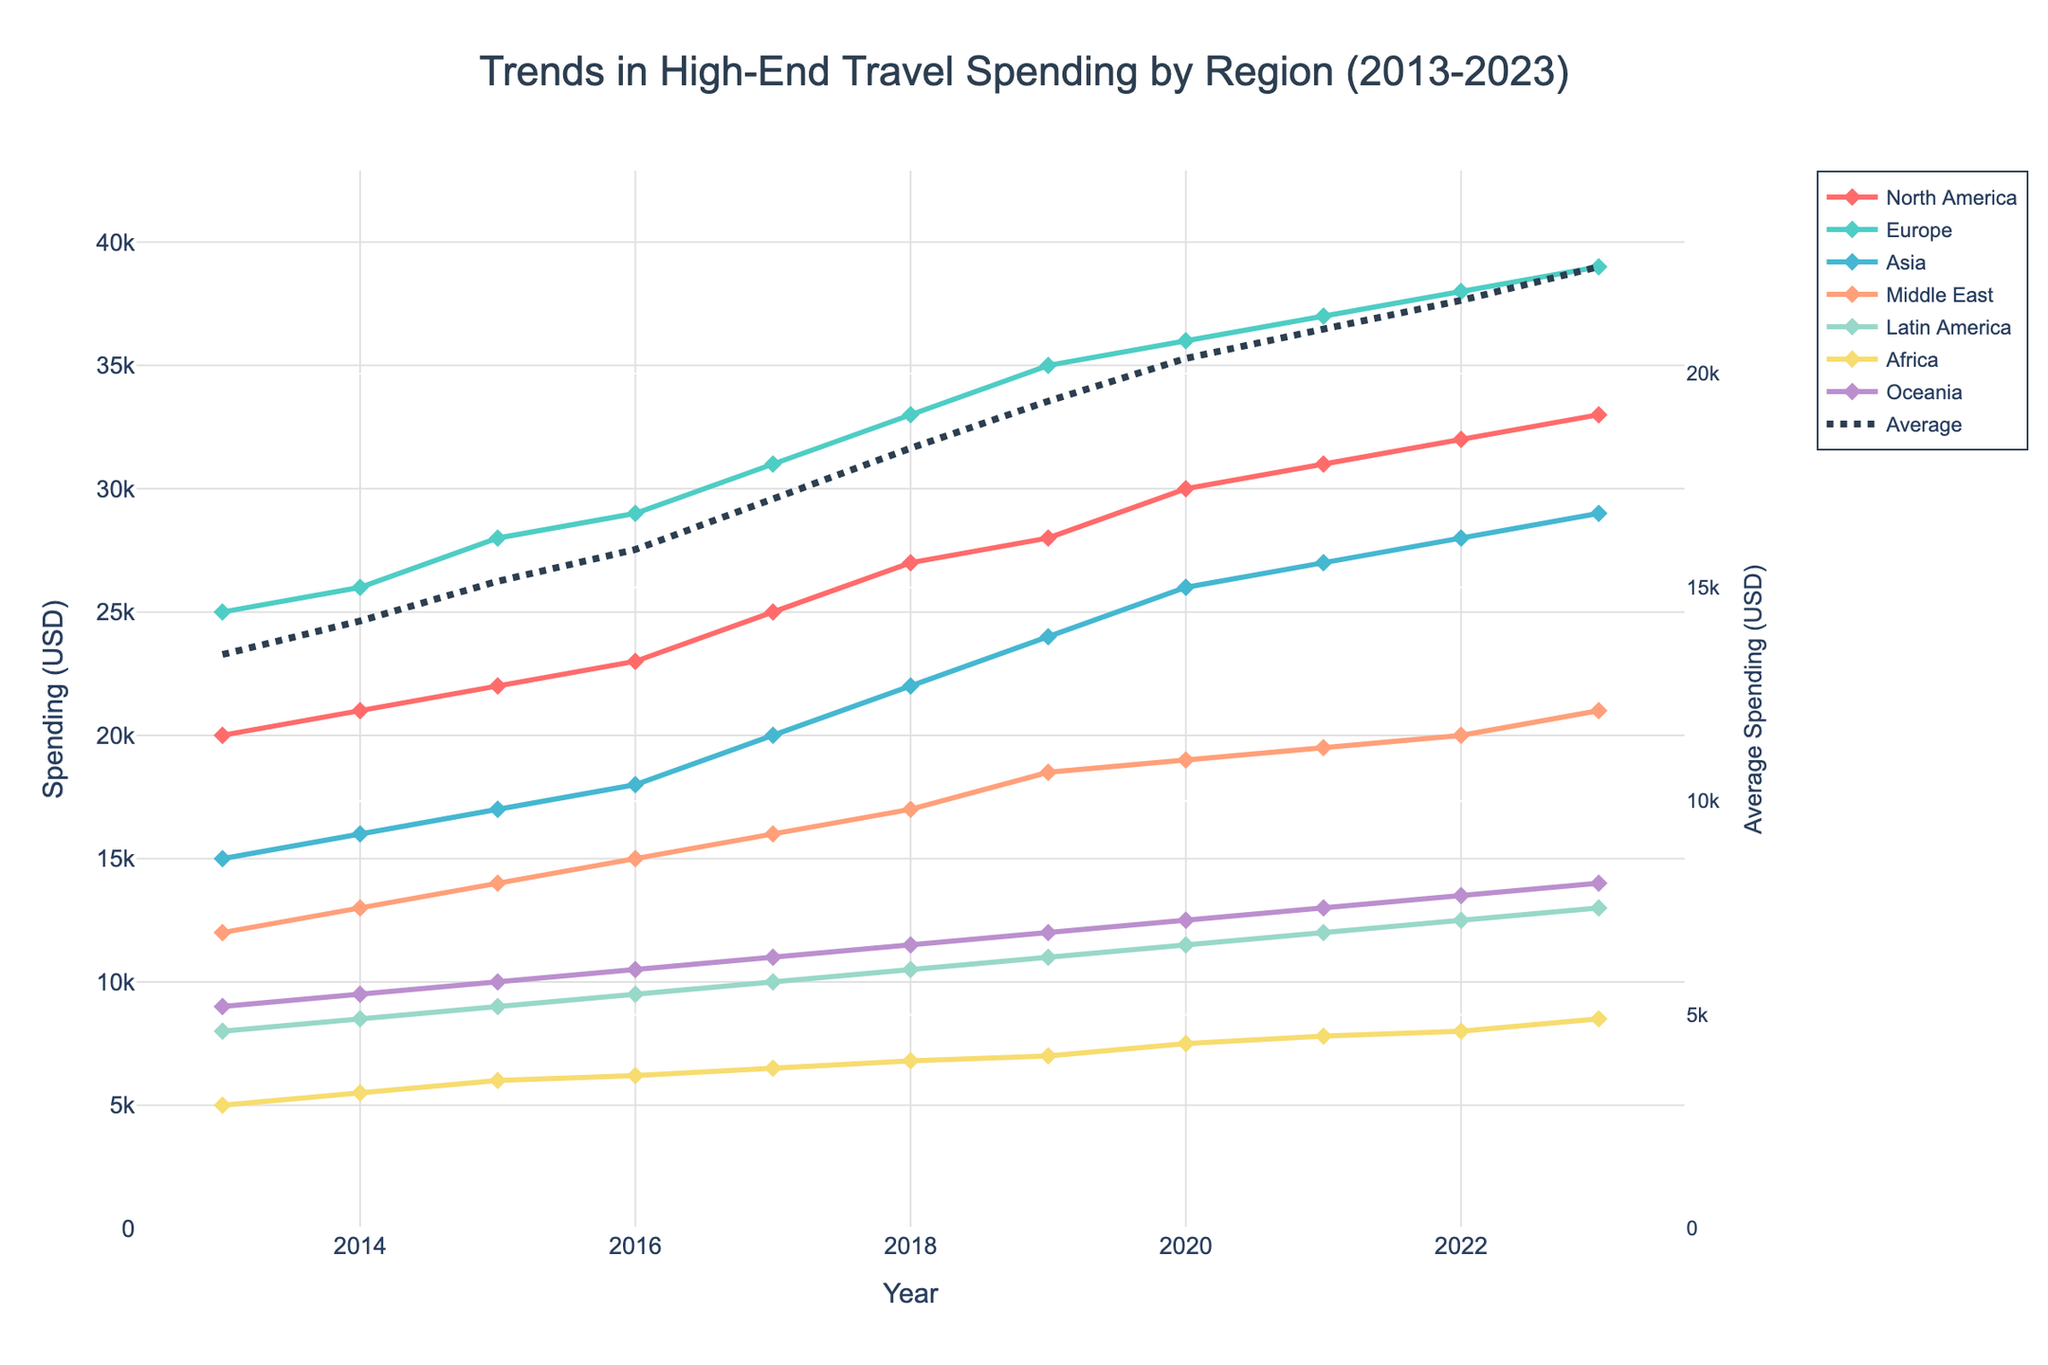What's the title of the figure? The title of the figure is found at the top of the chart. It reads, "Trends in High-End Travel Spending by Region (2013-2023)."
Answer: Trends in High-End Travel Spending by Region (2013-2023) What is the average spending value in 2023? To find the average spending value, locate the average line for 2023 and read the value on the secondary y-axis. The average spending for 2023 is approximately $27,000.
Answer: 27,000 USD Which region had the highest travel spending in 2019? Check the points for each region plotted in 2019. The highest point is for Europe, with a value of $35,000.
Answer: Europe How did spending trends in Asia change from 2013 to 2023? Observe the line representing Asia. It starts at $15,000 in 2013 and increases steadily to $29,000 in 2023.
Answer: Increased from 15,000 to 29,000 USD By how much did North America's travel spending increase from 2020 to 2023? Find the values for North America in 2020 and 2023. Subtract the 2020 value ($30,000) from the 2023 value ($33,000). The increase is $3,000.
Answer: 3,000 USD Which region showed the most consistent increase in spending over the decade? Analyze the steepness and regularity of the lines. Europe has a steady and consistent increase compared to other regions, as it rises evenly each year.
Answer: Europe What is the range of travel spending for Oceania in the dataset? Find the minimum and maximum values for Oceania. It ranges from $9,000 in 2013 to $14,000 in 2023. The range is $5,000.
Answer: 5,000 USD How does the Middle East's spending in 2017 compare to its spending in 2023? Locate the points for the Middle East in 2017 and 2023. In 2017, it is $16,000, and in 2023, it is $21,000. The spending increased by $5,000.
Answer: Increased by 5,000 USD Describe the trend for Africa's travel spending. The line representing Africa shows a gradual increase from $5,000 in 2013 to $8,500 in 2023, with small but consistent increments each year.
Answer: Gradual increase 